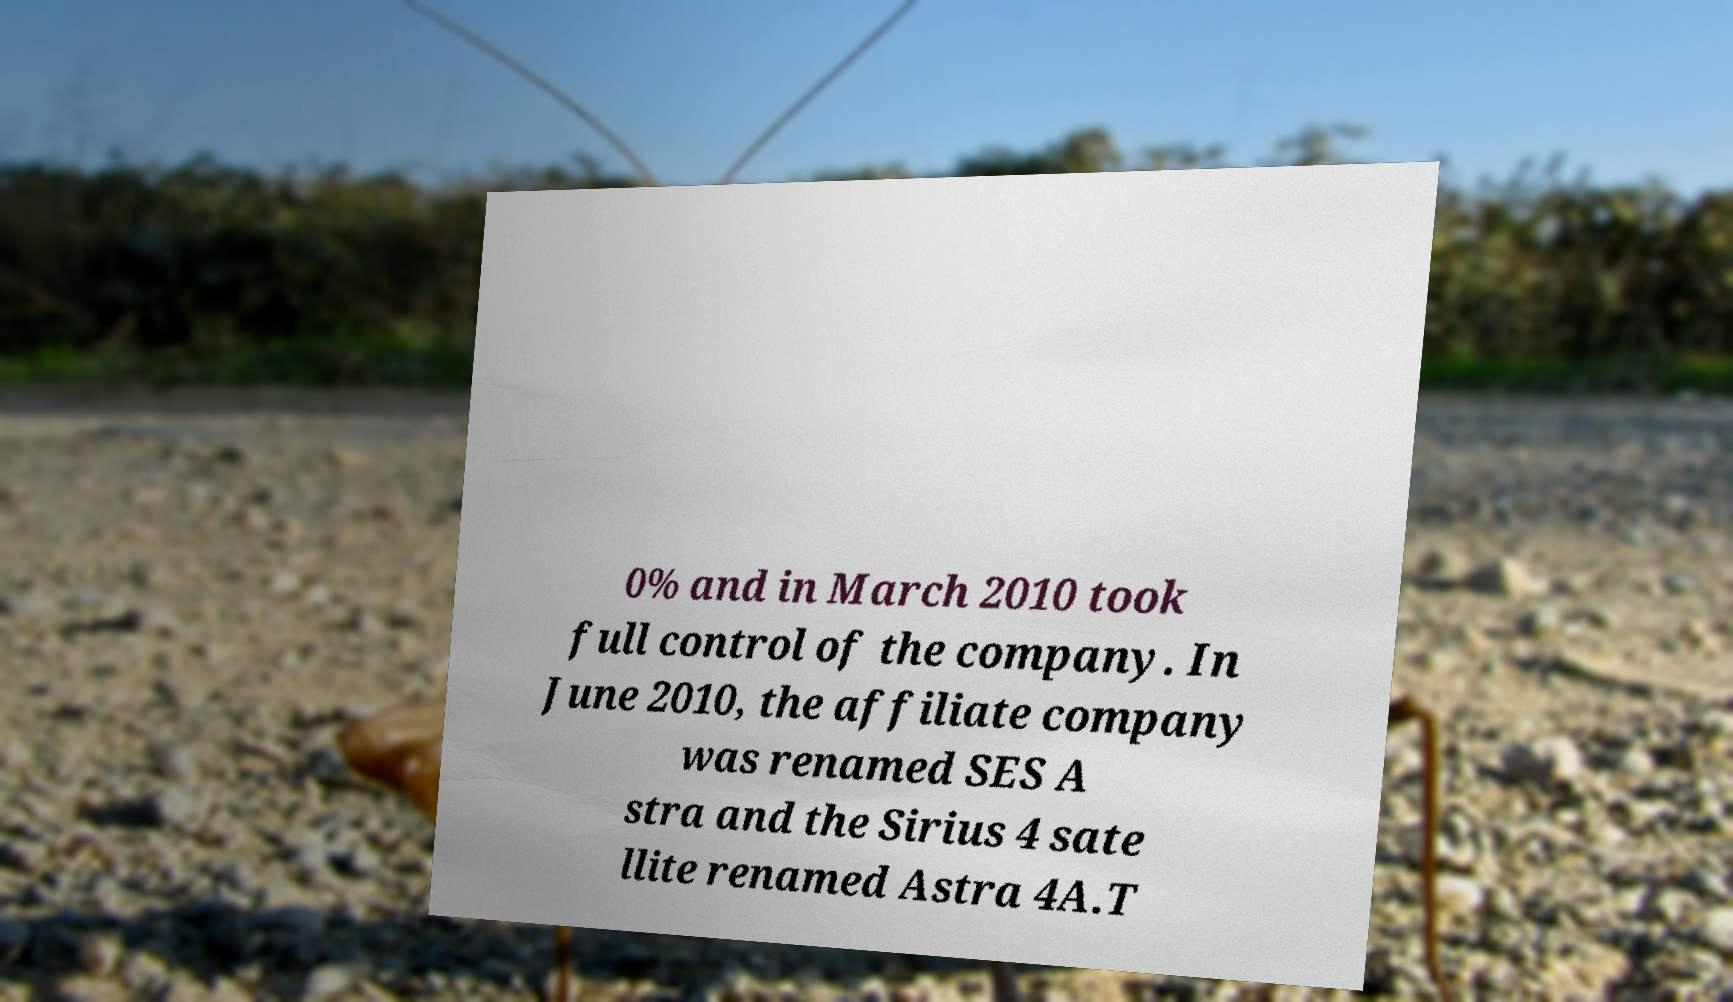Please identify and transcribe the text found in this image. 0% and in March 2010 took full control of the company. In June 2010, the affiliate company was renamed SES A stra and the Sirius 4 sate llite renamed Astra 4A.T 